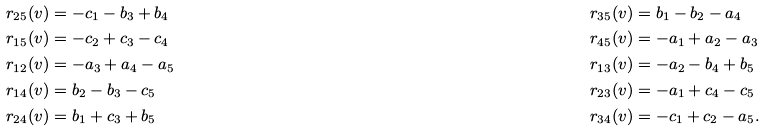Convert formula to latex. <formula><loc_0><loc_0><loc_500><loc_500>r _ { 2 5 } ( v ) & = - c _ { 1 } - b _ { 3 } + b _ { 4 } & r _ { 3 5 } ( v ) & = b _ { 1 } - b _ { 2 } - a _ { 4 } \\ r _ { 1 5 } ( v ) & = - c _ { 2 } + c _ { 3 } - c _ { 4 } & r _ { 4 5 } ( v ) & = - a _ { 1 } + a _ { 2 } - a _ { 3 } \\ r _ { 1 2 } ( v ) & = - a _ { 3 } + a _ { 4 } - a _ { 5 } & r _ { 1 3 } ( v ) & = - a _ { 2 } - b _ { 4 } + b _ { 5 } \\ r _ { 1 4 } ( v ) & = b _ { 2 } - b _ { 3 } - c _ { 5 } & r _ { 2 3 } ( v ) & = - a _ { 1 } + c _ { 4 } - c _ { 5 } \\ r _ { 2 4 } ( v ) & = b _ { 1 } + c _ { 3 } + b _ { 5 } & r _ { 3 4 } ( v ) & = - c _ { 1 } + c _ { 2 } - a _ { 5 } .</formula> 